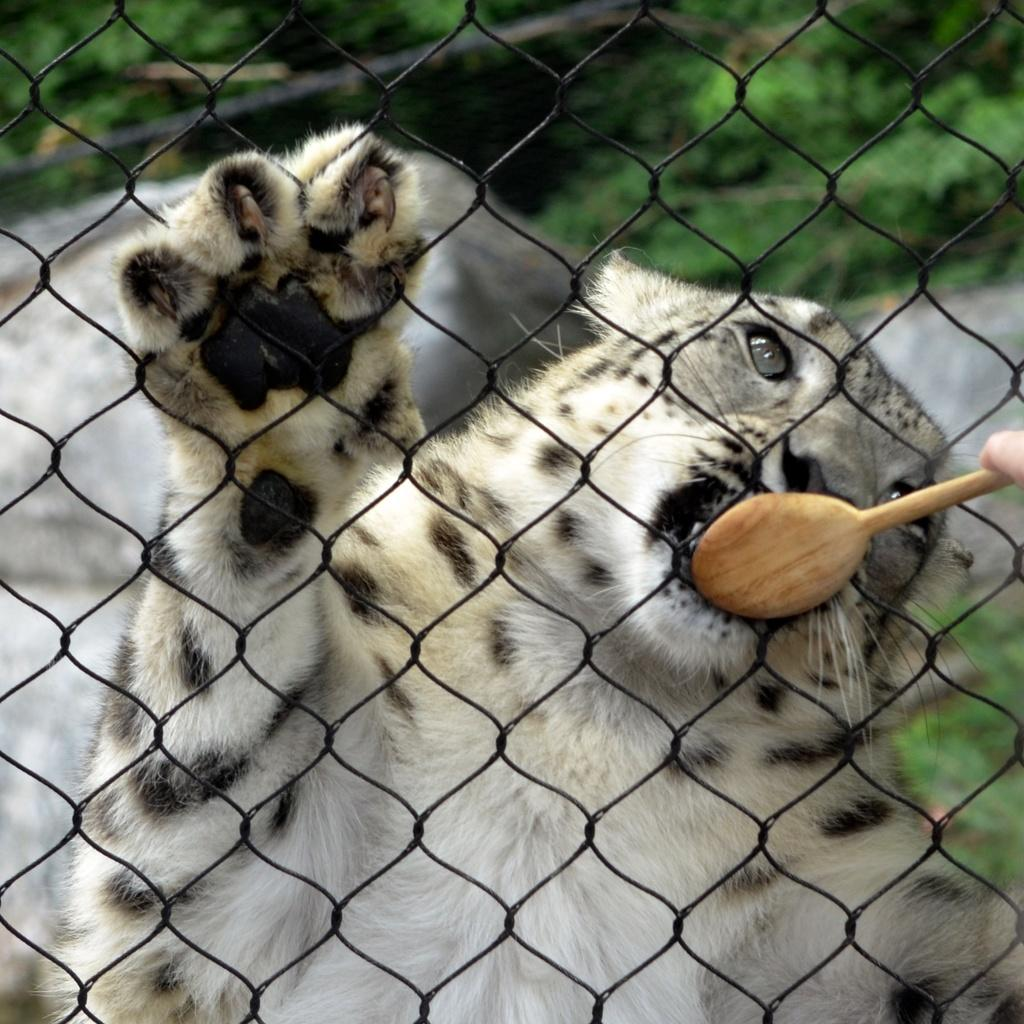What type of animal can be seen in the image? There is an animal in the image, but its specific type cannot be determined from the provided facts. What is the purpose of the fencing net in the image? The purpose of the fencing net in the image cannot be determined from the provided facts. What object is used for eating or scooping in the image? There is a spoon in the image, which is typically used for eating or scooping. What type of natural environment is visible in the background of the image? The background of the image includes grass, rocks, and plants, which suggests a natural environment. Can you tell me how many snakes are sleeping on the swing in the image? There are no snakes or swings present in the image. 